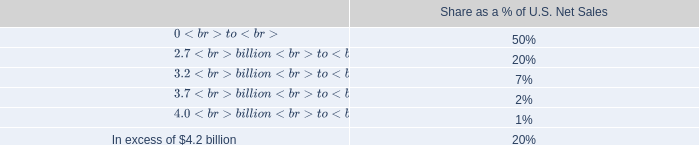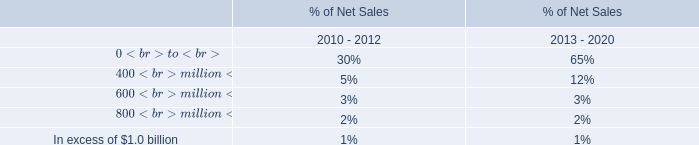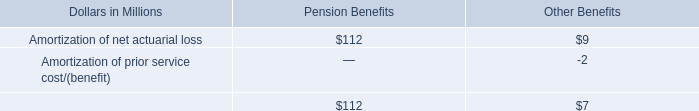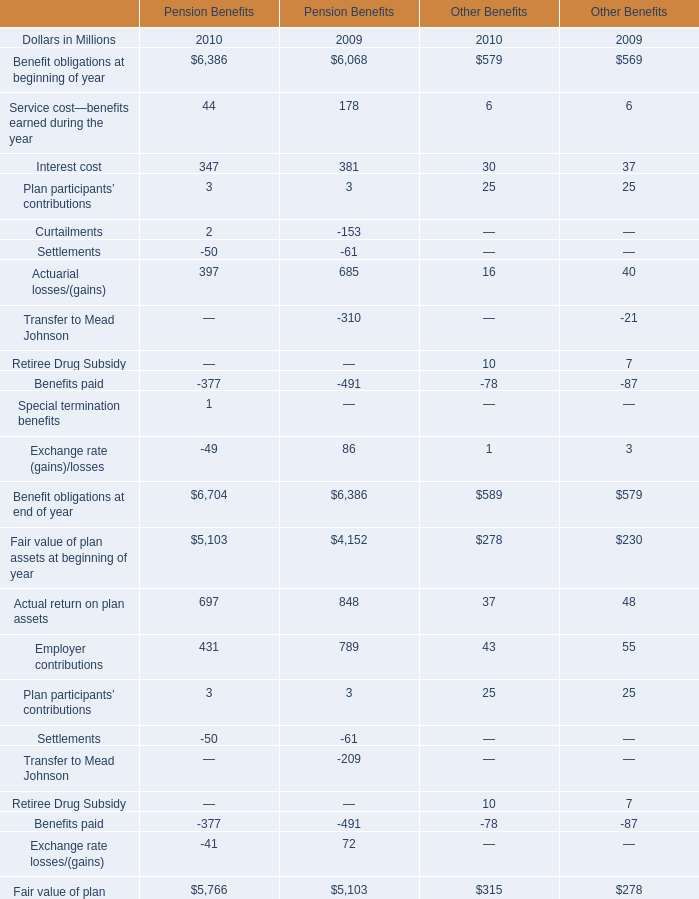What is the sum of Amortization of net actuarial loss for Pension Benefits and Employer contributions of Other Benefits in 2009? (in million) 
Computations: (112 + 55)
Answer: 167.0. 